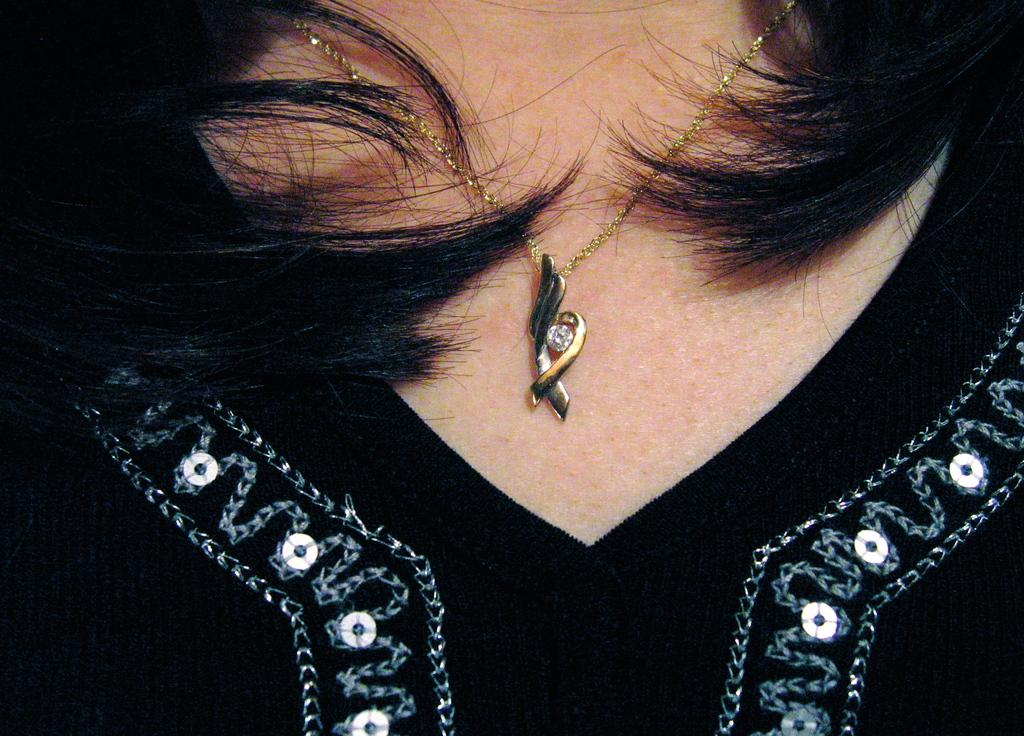What is the main subject of the image? There is a person in the image. What object can be seen near the person? There is a chain in the image. What physical feature of the person is visible? Hair is visible in the image. What type of trade is being conducted in the image? There is no indication of any trade being conducted in the image. Can you see any smoke in the image? There is no smoke visible in the image. 